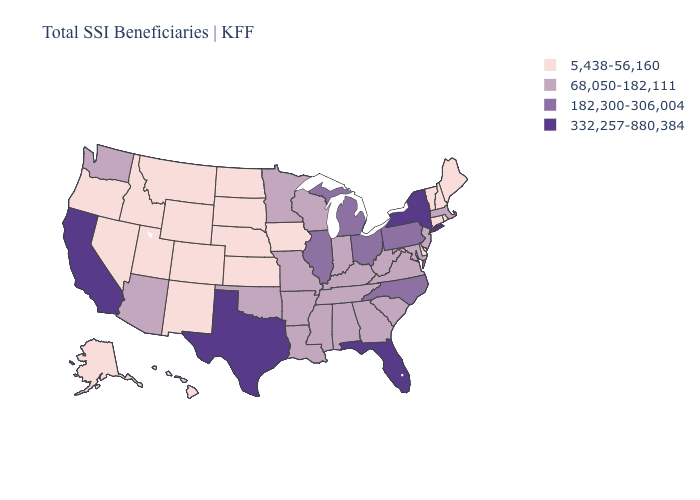Does Tennessee have the lowest value in the USA?
Keep it brief. No. What is the value of Iowa?
Be succinct. 5,438-56,160. Does Illinois have the highest value in the MidWest?
Write a very short answer. Yes. Does the first symbol in the legend represent the smallest category?
Be succinct. Yes. What is the highest value in states that border New York?
Short answer required. 182,300-306,004. Does the map have missing data?
Keep it brief. No. What is the value of South Dakota?
Give a very brief answer. 5,438-56,160. Which states have the highest value in the USA?
Be succinct. California, Florida, New York, Texas. Does Illinois have the same value as Idaho?
Be succinct. No. What is the lowest value in the USA?
Be succinct. 5,438-56,160. Name the states that have a value in the range 182,300-306,004?
Be succinct. Illinois, Michigan, North Carolina, Ohio, Pennsylvania. Does the map have missing data?
Short answer required. No. Is the legend a continuous bar?
Answer briefly. No. Among the states that border Ohio , which have the highest value?
Write a very short answer. Michigan, Pennsylvania. 